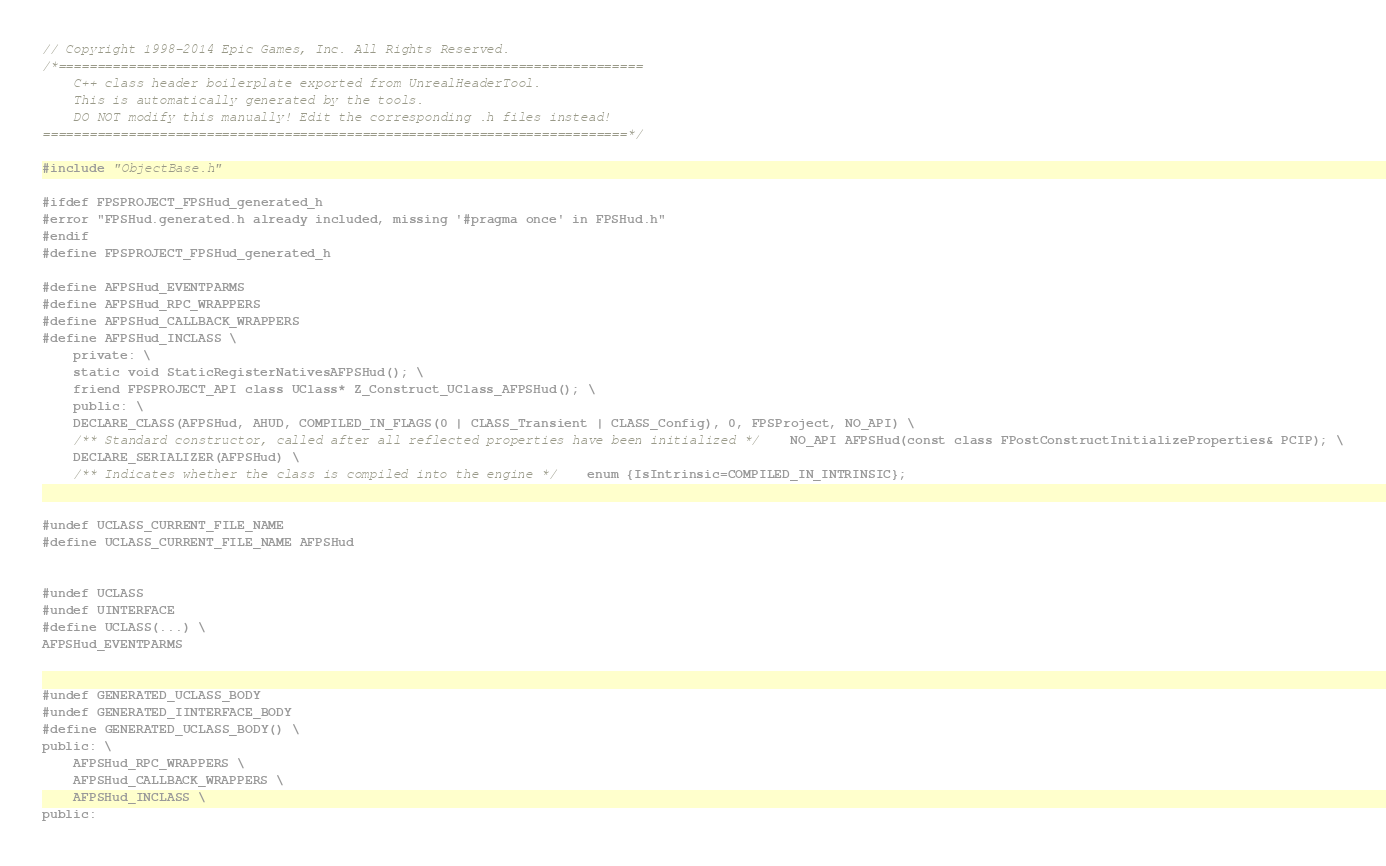Convert code to text. <code><loc_0><loc_0><loc_500><loc_500><_C_>// Copyright 1998-2014 Epic Games, Inc. All Rights Reserved.
/*===========================================================================
	C++ class header boilerplate exported from UnrealHeaderTool.
	This is automatically generated by the tools.
	DO NOT modify this manually! Edit the corresponding .h files instead!
===========================================================================*/

#include "ObjectBase.h"

#ifdef FPSPROJECT_FPSHud_generated_h
#error "FPSHud.generated.h already included, missing '#pragma once' in FPSHud.h"
#endif
#define FPSPROJECT_FPSHud_generated_h

#define AFPSHud_EVENTPARMS
#define AFPSHud_RPC_WRAPPERS
#define AFPSHud_CALLBACK_WRAPPERS
#define AFPSHud_INCLASS \
	private: \
	static void StaticRegisterNativesAFPSHud(); \
	friend FPSPROJECT_API class UClass* Z_Construct_UClass_AFPSHud(); \
	public: \
	DECLARE_CLASS(AFPSHud, AHUD, COMPILED_IN_FLAGS(0 | CLASS_Transient | CLASS_Config), 0, FPSProject, NO_API) \
	/** Standard constructor, called after all reflected properties have been initialized */    NO_API AFPSHud(const class FPostConstructInitializeProperties& PCIP); \
	DECLARE_SERIALIZER(AFPSHud) \
	/** Indicates whether the class is compiled into the engine */    enum {IsIntrinsic=COMPILED_IN_INTRINSIC};


#undef UCLASS_CURRENT_FILE_NAME
#define UCLASS_CURRENT_FILE_NAME AFPSHud


#undef UCLASS
#undef UINTERFACE
#define UCLASS(...) \
AFPSHud_EVENTPARMS


#undef GENERATED_UCLASS_BODY
#undef GENERATED_IINTERFACE_BODY
#define GENERATED_UCLASS_BODY() \
public: \
	AFPSHud_RPC_WRAPPERS \
	AFPSHud_CALLBACK_WRAPPERS \
	AFPSHud_INCLASS \
public:


</code> 